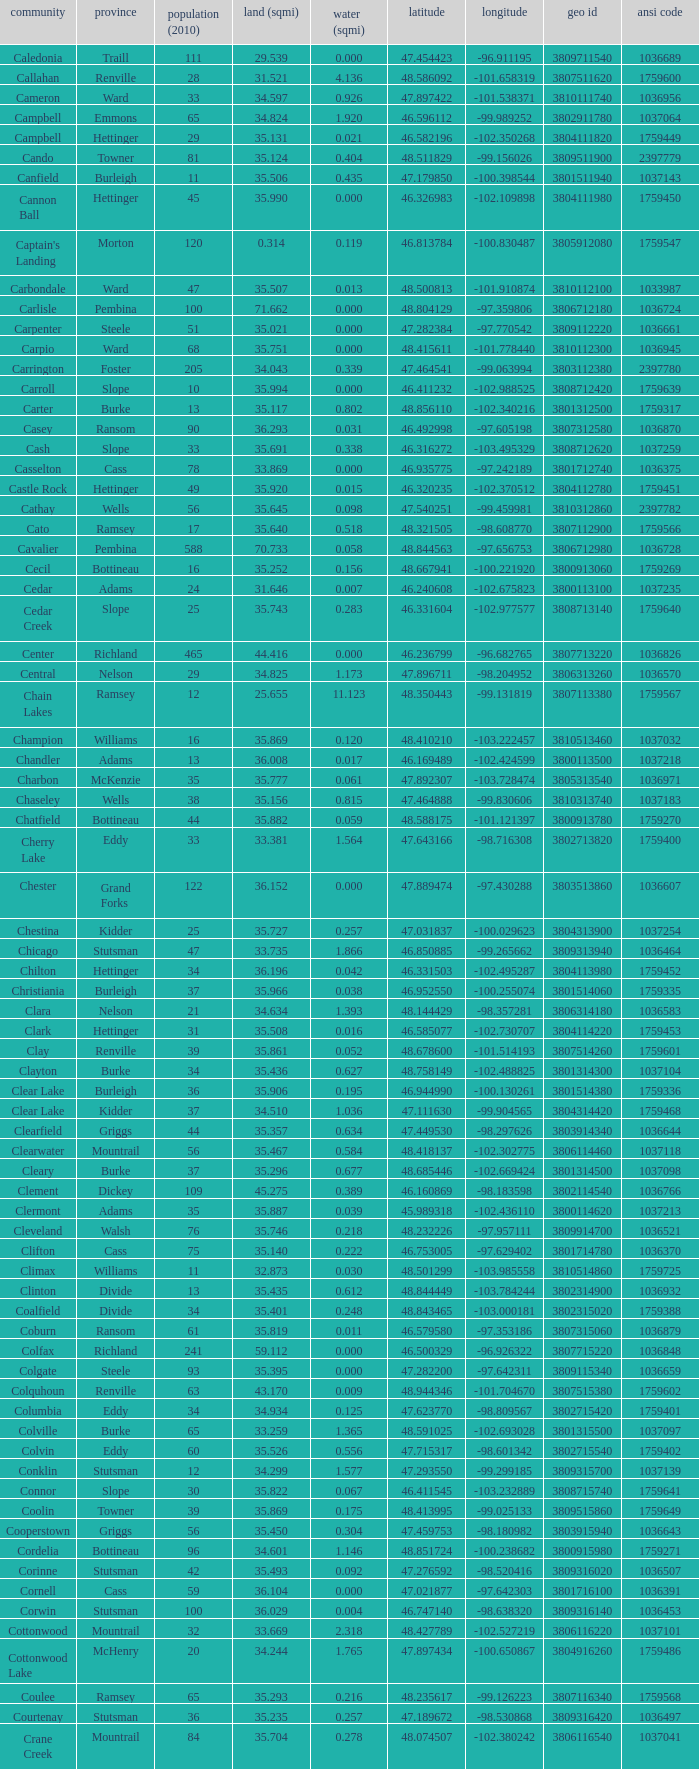Can you parse all the data within this table? {'header': ['community', 'province', 'population (2010)', 'land (sqmi)', 'water (sqmi)', 'latitude', 'longitude', 'geo id', 'ansi code'], 'rows': [['Caledonia', 'Traill', '111', '29.539', '0.000', '47.454423', '-96.911195', '3809711540', '1036689'], ['Callahan', 'Renville', '28', '31.521', '4.136', '48.586092', '-101.658319', '3807511620', '1759600'], ['Cameron', 'Ward', '33', '34.597', '0.926', '47.897422', '-101.538371', '3810111740', '1036956'], ['Campbell', 'Emmons', '65', '34.824', '1.920', '46.596112', '-99.989252', '3802911780', '1037064'], ['Campbell', 'Hettinger', '29', '35.131', '0.021', '46.582196', '-102.350268', '3804111820', '1759449'], ['Cando', 'Towner', '81', '35.124', '0.404', '48.511829', '-99.156026', '3809511900', '2397779'], ['Canfield', 'Burleigh', '11', '35.506', '0.435', '47.179850', '-100.398544', '3801511940', '1037143'], ['Cannon Ball', 'Hettinger', '45', '35.990', '0.000', '46.326983', '-102.109898', '3804111980', '1759450'], ["Captain's Landing", 'Morton', '120', '0.314', '0.119', '46.813784', '-100.830487', '3805912080', '1759547'], ['Carbondale', 'Ward', '47', '35.507', '0.013', '48.500813', '-101.910874', '3810112100', '1033987'], ['Carlisle', 'Pembina', '100', '71.662', '0.000', '48.804129', '-97.359806', '3806712180', '1036724'], ['Carpenter', 'Steele', '51', '35.021', '0.000', '47.282384', '-97.770542', '3809112220', '1036661'], ['Carpio', 'Ward', '68', '35.751', '0.000', '48.415611', '-101.778440', '3810112300', '1036945'], ['Carrington', 'Foster', '205', '34.043', '0.339', '47.464541', '-99.063994', '3803112380', '2397780'], ['Carroll', 'Slope', '10', '35.994', '0.000', '46.411232', '-102.988525', '3808712420', '1759639'], ['Carter', 'Burke', '13', '35.117', '0.802', '48.856110', '-102.340216', '3801312500', '1759317'], ['Casey', 'Ransom', '90', '36.293', '0.031', '46.492998', '-97.605198', '3807312580', '1036870'], ['Cash', 'Slope', '33', '35.691', '0.338', '46.316272', '-103.495329', '3808712620', '1037259'], ['Casselton', 'Cass', '78', '33.869', '0.000', '46.935775', '-97.242189', '3801712740', '1036375'], ['Castle Rock', 'Hettinger', '49', '35.920', '0.015', '46.320235', '-102.370512', '3804112780', '1759451'], ['Cathay', 'Wells', '56', '35.645', '0.098', '47.540251', '-99.459981', '3810312860', '2397782'], ['Cato', 'Ramsey', '17', '35.640', '0.518', '48.321505', '-98.608770', '3807112900', '1759566'], ['Cavalier', 'Pembina', '588', '70.733', '0.058', '48.844563', '-97.656753', '3806712980', '1036728'], ['Cecil', 'Bottineau', '16', '35.252', '0.156', '48.667941', '-100.221920', '3800913060', '1759269'], ['Cedar', 'Adams', '24', '31.646', '0.007', '46.240608', '-102.675823', '3800113100', '1037235'], ['Cedar Creek', 'Slope', '25', '35.743', '0.283', '46.331604', '-102.977577', '3808713140', '1759640'], ['Center', 'Richland', '465', '44.416', '0.000', '46.236799', '-96.682765', '3807713220', '1036826'], ['Central', 'Nelson', '29', '34.825', '1.173', '47.896711', '-98.204952', '3806313260', '1036570'], ['Chain Lakes', 'Ramsey', '12', '25.655', '11.123', '48.350443', '-99.131819', '3807113380', '1759567'], ['Champion', 'Williams', '16', '35.869', '0.120', '48.410210', '-103.222457', '3810513460', '1037032'], ['Chandler', 'Adams', '13', '36.008', '0.017', '46.169489', '-102.424599', '3800113500', '1037218'], ['Charbon', 'McKenzie', '35', '35.777', '0.061', '47.892307', '-103.728474', '3805313540', '1036971'], ['Chaseley', 'Wells', '38', '35.156', '0.815', '47.464888', '-99.830606', '3810313740', '1037183'], ['Chatfield', 'Bottineau', '44', '35.882', '0.059', '48.588175', '-101.121397', '3800913780', '1759270'], ['Cherry Lake', 'Eddy', '33', '33.381', '1.564', '47.643166', '-98.716308', '3802713820', '1759400'], ['Chester', 'Grand Forks', '122', '36.152', '0.000', '47.889474', '-97.430288', '3803513860', '1036607'], ['Chestina', 'Kidder', '25', '35.727', '0.257', '47.031837', '-100.029623', '3804313900', '1037254'], ['Chicago', 'Stutsman', '47', '33.735', '1.866', '46.850885', '-99.265662', '3809313940', '1036464'], ['Chilton', 'Hettinger', '34', '36.196', '0.042', '46.331503', '-102.495287', '3804113980', '1759452'], ['Christiania', 'Burleigh', '37', '35.966', '0.038', '46.952550', '-100.255074', '3801514060', '1759335'], ['Clara', 'Nelson', '21', '34.634', '1.393', '48.144429', '-98.357281', '3806314180', '1036583'], ['Clark', 'Hettinger', '31', '35.508', '0.016', '46.585077', '-102.730707', '3804114220', '1759453'], ['Clay', 'Renville', '39', '35.861', '0.052', '48.678600', '-101.514193', '3807514260', '1759601'], ['Clayton', 'Burke', '34', '35.436', '0.627', '48.758149', '-102.488825', '3801314300', '1037104'], ['Clear Lake', 'Burleigh', '36', '35.906', '0.195', '46.944990', '-100.130261', '3801514380', '1759336'], ['Clear Lake', 'Kidder', '37', '34.510', '1.036', '47.111630', '-99.904565', '3804314420', '1759468'], ['Clearfield', 'Griggs', '44', '35.357', '0.634', '47.449530', '-98.297626', '3803914340', '1036644'], ['Clearwater', 'Mountrail', '56', '35.467', '0.584', '48.418137', '-102.302775', '3806114460', '1037118'], ['Cleary', 'Burke', '37', '35.296', '0.677', '48.685446', '-102.669424', '3801314500', '1037098'], ['Clement', 'Dickey', '109', '45.275', '0.389', '46.160869', '-98.183598', '3802114540', '1036766'], ['Clermont', 'Adams', '35', '35.887', '0.039', '45.989318', '-102.436110', '3800114620', '1037213'], ['Cleveland', 'Walsh', '76', '35.746', '0.218', '48.232226', '-97.957111', '3809914700', '1036521'], ['Clifton', 'Cass', '75', '35.140', '0.222', '46.753005', '-97.629402', '3801714780', '1036370'], ['Climax', 'Williams', '11', '32.873', '0.030', '48.501299', '-103.985558', '3810514860', '1759725'], ['Clinton', 'Divide', '13', '35.435', '0.612', '48.844449', '-103.784244', '3802314900', '1036932'], ['Coalfield', 'Divide', '34', '35.401', '0.248', '48.843465', '-103.000181', '3802315020', '1759388'], ['Coburn', 'Ransom', '61', '35.819', '0.011', '46.579580', '-97.353186', '3807315060', '1036879'], ['Colfax', 'Richland', '241', '59.112', '0.000', '46.500329', '-96.926322', '3807715220', '1036848'], ['Colgate', 'Steele', '93', '35.395', '0.000', '47.282200', '-97.642311', '3809115340', '1036659'], ['Colquhoun', 'Renville', '63', '43.170', '0.009', '48.944346', '-101.704670', '3807515380', '1759602'], ['Columbia', 'Eddy', '34', '34.934', '0.125', '47.623770', '-98.809567', '3802715420', '1759401'], ['Colville', 'Burke', '65', '33.259', '1.365', '48.591025', '-102.693028', '3801315500', '1037097'], ['Colvin', 'Eddy', '60', '35.526', '0.556', '47.715317', '-98.601342', '3802715540', '1759402'], ['Conklin', 'Stutsman', '12', '34.299', '1.577', '47.293550', '-99.299185', '3809315700', '1037139'], ['Connor', 'Slope', '30', '35.822', '0.067', '46.411545', '-103.232889', '3808715740', '1759641'], ['Coolin', 'Towner', '39', '35.869', '0.175', '48.413995', '-99.025133', '3809515860', '1759649'], ['Cooperstown', 'Griggs', '56', '35.450', '0.304', '47.459753', '-98.180982', '3803915940', '1036643'], ['Cordelia', 'Bottineau', '96', '34.601', '1.146', '48.851724', '-100.238682', '3800915980', '1759271'], ['Corinne', 'Stutsman', '42', '35.493', '0.092', '47.276592', '-98.520416', '3809316020', '1036507'], ['Cornell', 'Cass', '59', '36.104', '0.000', '47.021877', '-97.642303', '3801716100', '1036391'], ['Corwin', 'Stutsman', '100', '36.029', '0.004', '46.747140', '-98.638320', '3809316140', '1036453'], ['Cottonwood', 'Mountrail', '32', '33.669', '2.318', '48.427789', '-102.527219', '3806116220', '1037101'], ['Cottonwood Lake', 'McHenry', '20', '34.244', '1.765', '47.897434', '-100.650867', '3804916260', '1759486'], ['Coulee', 'Ramsey', '65', '35.293', '0.216', '48.235617', '-99.126223', '3807116340', '1759568'], ['Courtenay', 'Stutsman', '36', '35.235', '0.257', '47.189672', '-98.530868', '3809316420', '1036497'], ['Crane Creek', 'Mountrail', '84', '35.704', '0.278', '48.074507', '-102.380242', '3806116540', '1037041'], ['Crawford', 'Slope', '31', '35.892', '0.051', '46.320329', '-103.729934', '3808716620', '1037166'], ['Creel', 'Ramsey', '1305', '14.578', '15.621', '48.075823', '-98.857272', '3807116660', '1759569'], ['Cremerville', 'McLean', '27', '35.739', '0.054', '47.811011', '-102.054883', '3805516700', '1759530'], ['Crocus', 'Towner', '44', '35.047', '0.940', '48.667289', '-99.155787', '3809516820', '1759650'], ['Crofte', 'Burleigh', '199', '36.163', '0.000', '47.026425', '-100.685988', '3801516860', '1037131'], ['Cromwell', 'Burleigh', '35', '36.208', '0.000', '47.026008', '-100.558805', '3801516900', '1037133'], ['Crowfoot', 'Mountrail', '18', '34.701', '1.283', '48.495946', '-102.180433', '3806116980', '1037050'], ['Crown Hill', 'Kidder', '7', '30.799', '1.468', '46.770977', '-100.025924', '3804317020', '1759469'], ['Crystal', 'Pembina', '50', '35.499', '0.000', '48.586423', '-97.732145', '3806717100', '1036718'], ['Crystal Lake', 'Wells', '32', '35.522', '0.424', '47.541346', '-99.974737', '3810317140', '1037152'], ['Crystal Springs', 'Kidder', '32', '35.415', '0.636', '46.848792', '-99.529639', '3804317220', '1759470'], ['Cuba', 'Barnes', '76', '35.709', '0.032', '46.851144', '-97.860271', '3800317300', '1036409'], ['Cusator', 'Stutsman', '26', '34.878', '0.693', '46.746853', '-98.997611', '3809317460', '1036459'], ['Cut Bank', 'Bottineau', '37', '35.898', '0.033', '48.763937', '-101.430571', '3800917540', '1759272']]} For the township located at a latitude of 48.075823, what was its longitude? -98.857272. 